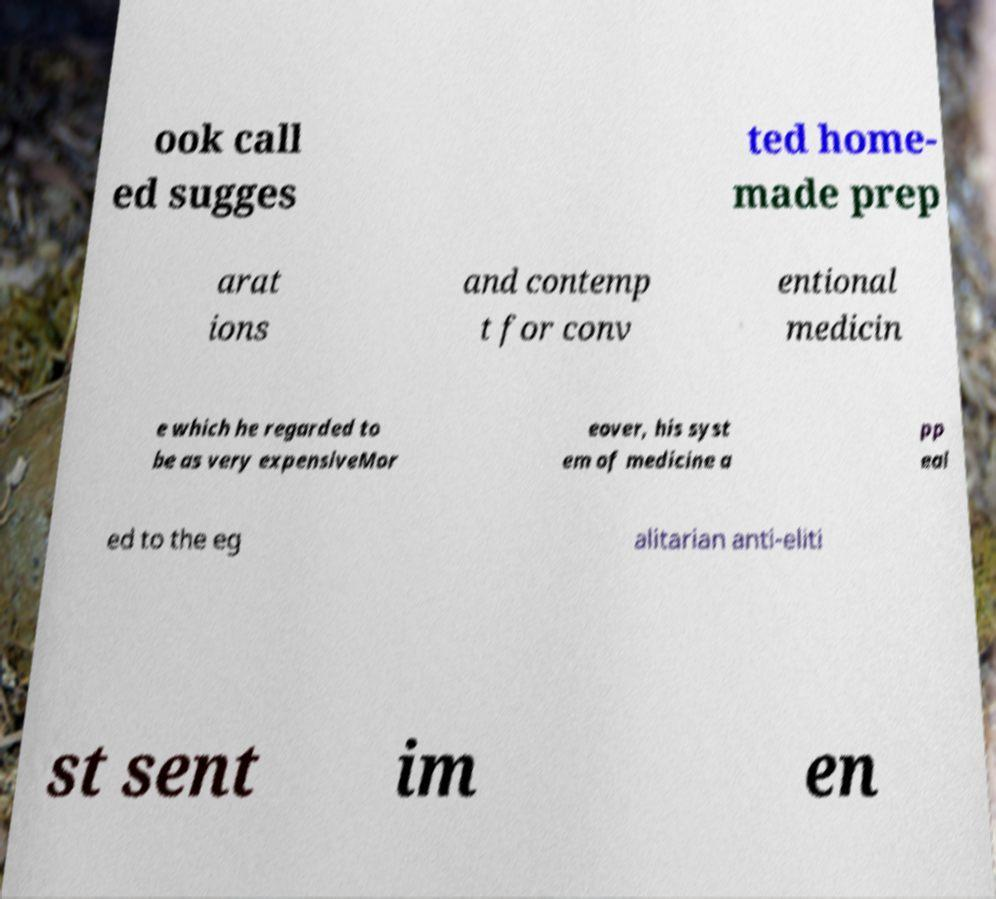Can you accurately transcribe the text from the provided image for me? ook call ed sugges ted home- made prep arat ions and contemp t for conv entional medicin e which he regarded to be as very expensiveMor eover, his syst em of medicine a pp eal ed to the eg alitarian anti-eliti st sent im en 